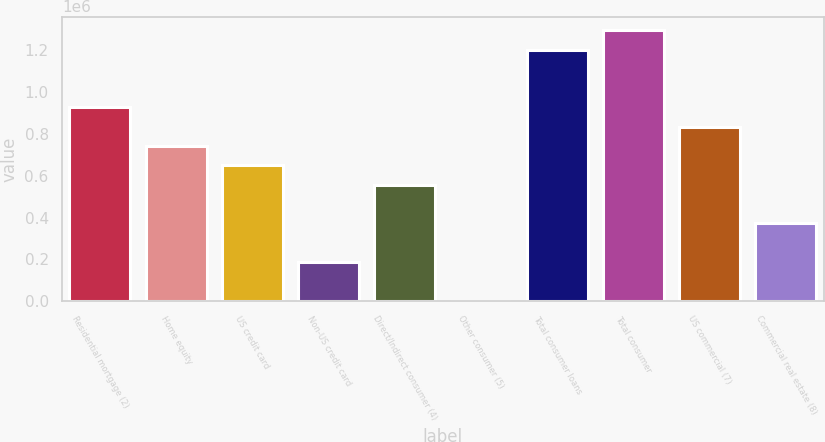<chart> <loc_0><loc_0><loc_500><loc_500><bar_chart><fcel>Residential mortgage (2)<fcel>Home equity<fcel>US credit card<fcel>Non-US credit card<fcel>Direct/Indirect consumer (4)<fcel>Other consumer (5)<fcel>Total consumer loans<fcel>Total consumer<fcel>US commercial (7)<fcel>Commercial real estate (8)<nl><fcel>926200<fcel>741498<fcel>649146<fcel>187390<fcel>556795<fcel>2688<fcel>1.20325e+06<fcel>1.2956e+06<fcel>833849<fcel>372093<nl></chart> 